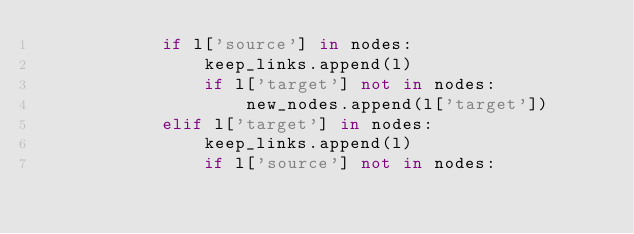<code> <loc_0><loc_0><loc_500><loc_500><_Python_>            if l['source'] in nodes:
                keep_links.append(l)
                if l['target'] not in nodes:
                    new_nodes.append(l['target'])
            elif l['target'] in nodes:
                keep_links.append(l)
                if l['source'] not in nodes:</code> 